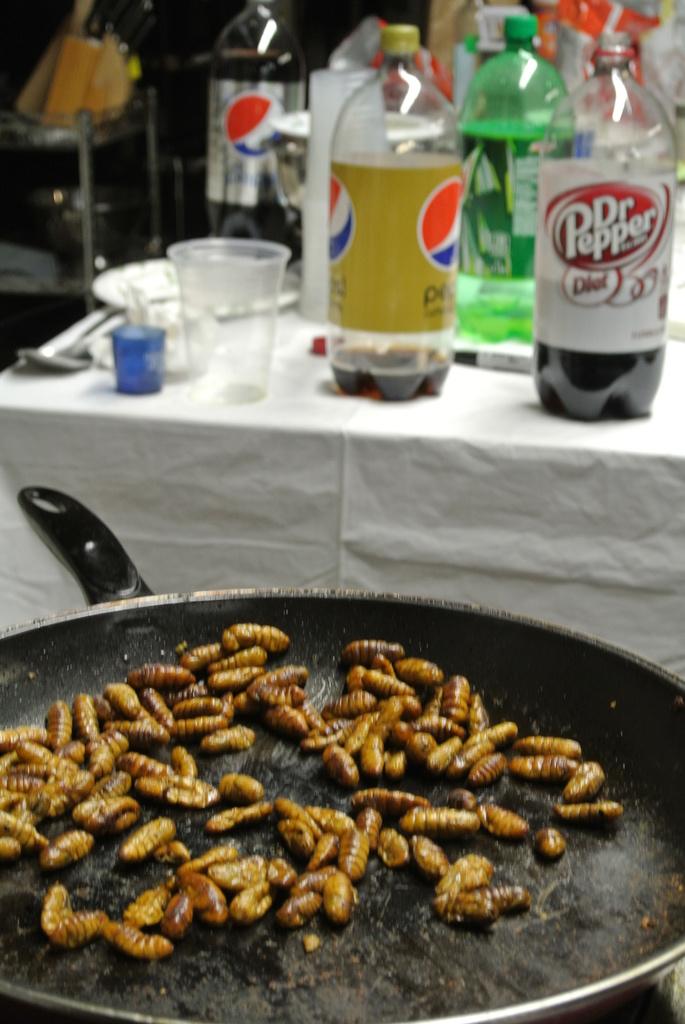What kind of soda is on the right side of the photo?
Give a very brief answer. Dr. pepper. 